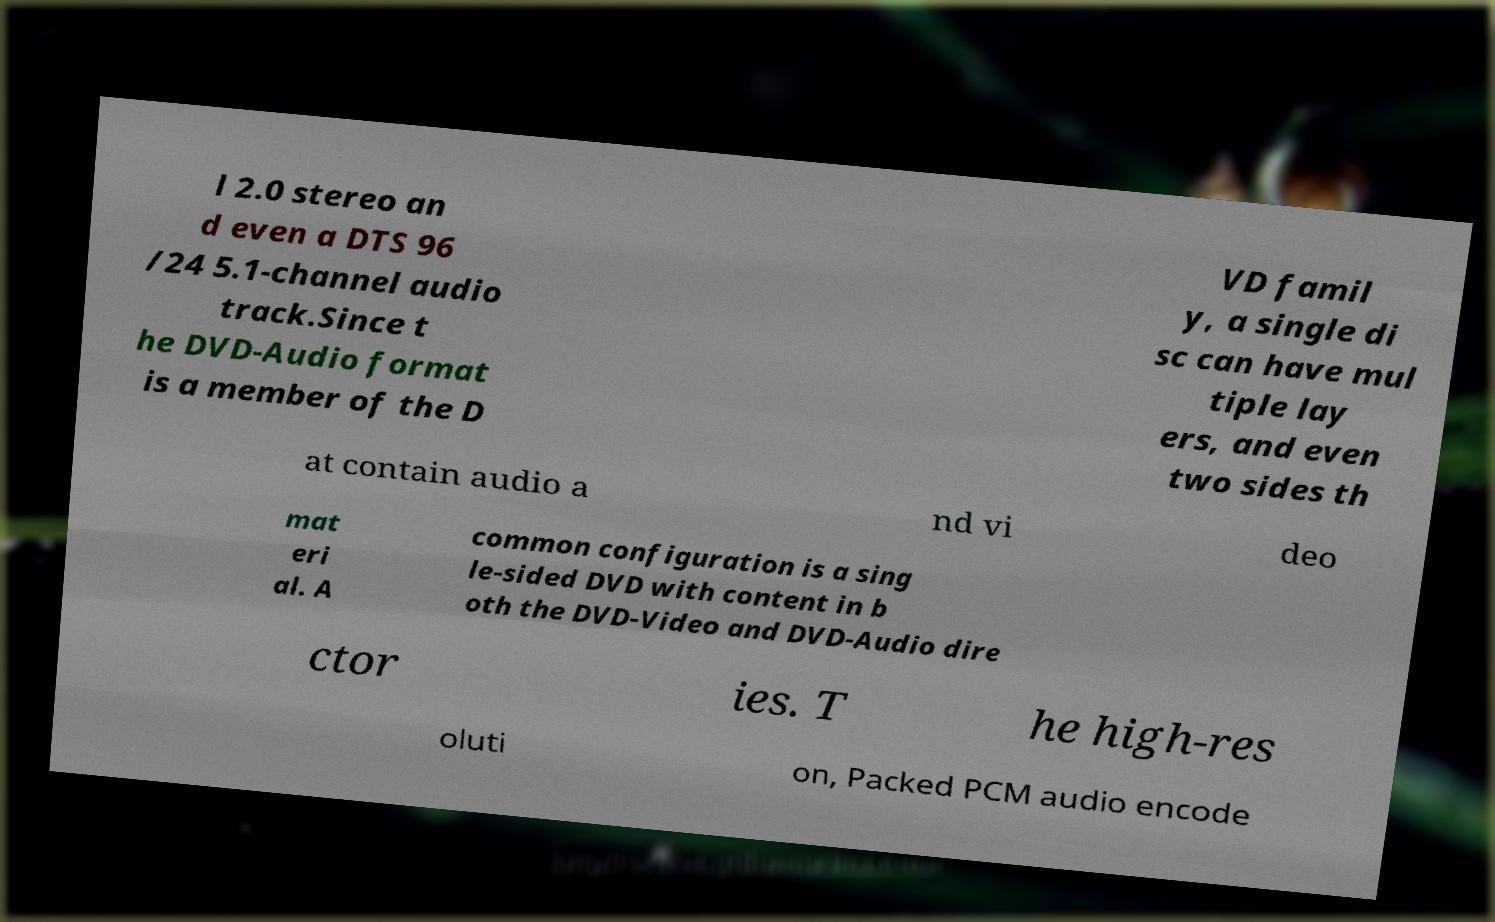Please identify and transcribe the text found in this image. l 2.0 stereo an d even a DTS 96 /24 5.1-channel audio track.Since t he DVD-Audio format is a member of the D VD famil y, a single di sc can have mul tiple lay ers, and even two sides th at contain audio a nd vi deo mat eri al. A common configuration is a sing le-sided DVD with content in b oth the DVD-Video and DVD-Audio dire ctor ies. T he high-res oluti on, Packed PCM audio encode 